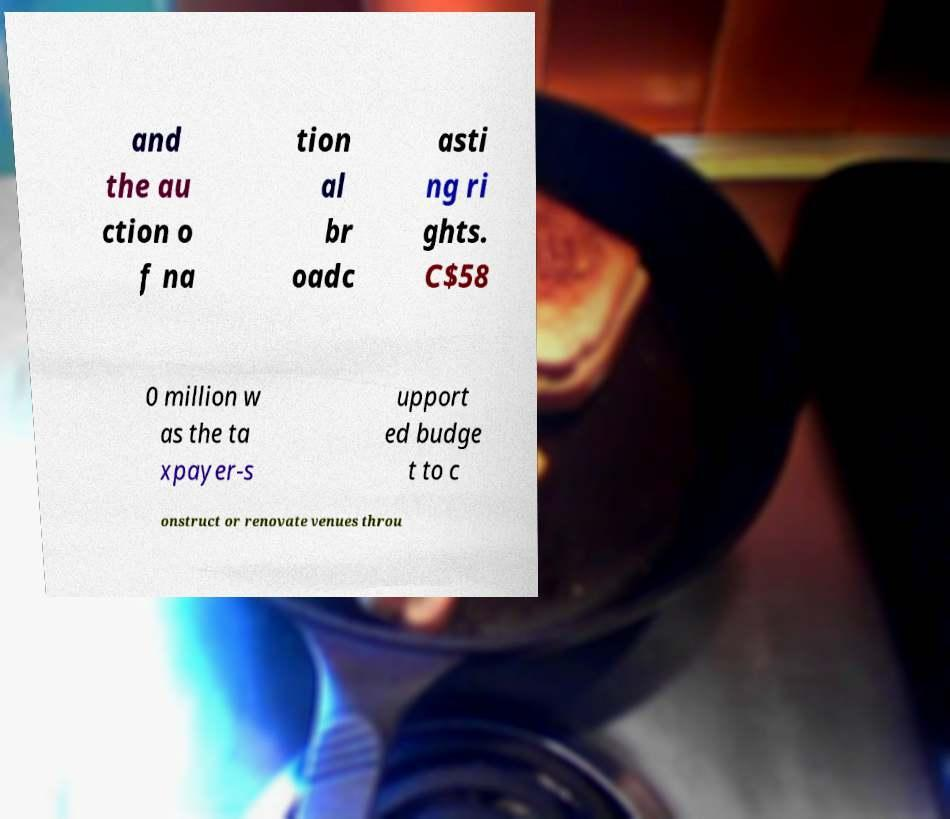Please read and relay the text visible in this image. What does it say? and the au ction o f na tion al br oadc asti ng ri ghts. C$58 0 million w as the ta xpayer-s upport ed budge t to c onstruct or renovate venues throu 